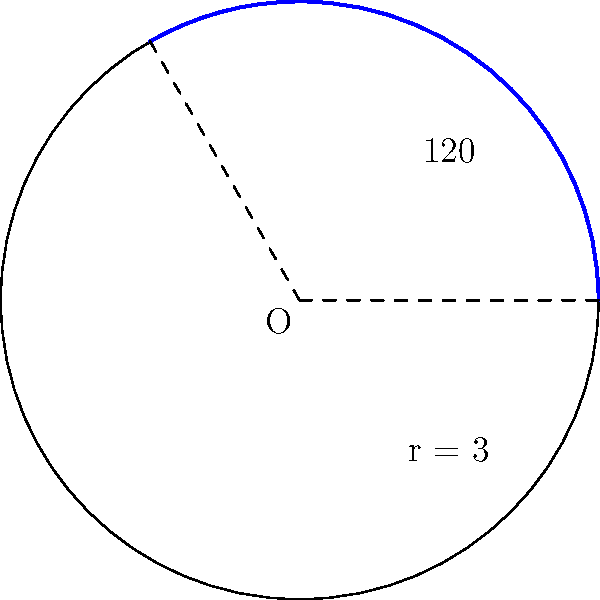In a circular sector with a central angle of 120° and a radius of 3 units, calculate the area of the sector. Round your answer to two decimal places. How might this relate to the distribution of resources in a policy that aims to energize youth voters? To solve this problem, we'll follow these steps:

1) The formula for the area of a circular sector is:

   $$A = \frac{\theta}{360°} \pi r^2$$

   Where $\theta$ is the central angle in degrees, and $r$ is the radius.

2) We're given:
   $\theta = 120°$
   $r = 3$ units

3) Let's substitute these values into our formula:

   $$A = \frac{120°}{360°} \pi (3)^2$$

4) Simplify:
   $$A = \frac{1}{3} \pi (9)$$
   $$A = 3\pi$$

5) Calculate and round to two decimal places:
   $$A \approx 9.42 \text{ square units}$$

This result could be analogous to allocating a third of total resources (represented by the full circle) to youth-focused policies, potentially energizing this demographic while maintaining a conservative approach to overall resource distribution.
Answer: $9.42 \text{ square units}$ 